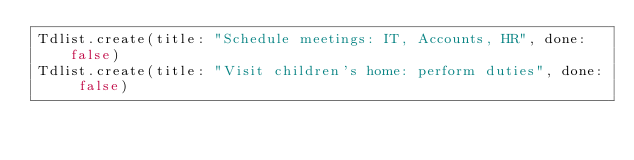Convert code to text. <code><loc_0><loc_0><loc_500><loc_500><_Ruby_>Tdlist.create(title: "Schedule meetings: IT, Accounts, HR", done: false)
Tdlist.create(title: "Visit children's home: perform duties", done: false)</code> 